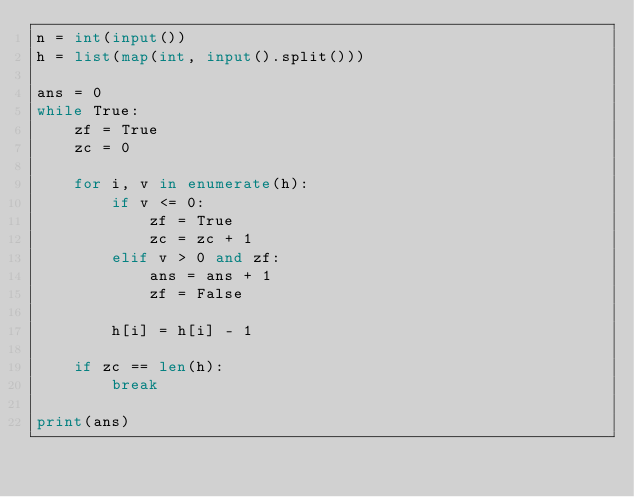<code> <loc_0><loc_0><loc_500><loc_500><_Python_>n = int(input())
h = list(map(int, input().split()))

ans = 0
while True:
    zf = True
    zc = 0

    for i, v in enumerate(h):
        if v <= 0:
            zf = True
            zc = zc + 1
        elif v > 0 and zf:
            ans = ans + 1
            zf = False

        h[i] = h[i] - 1

    if zc == len(h):
        break

print(ans)</code> 